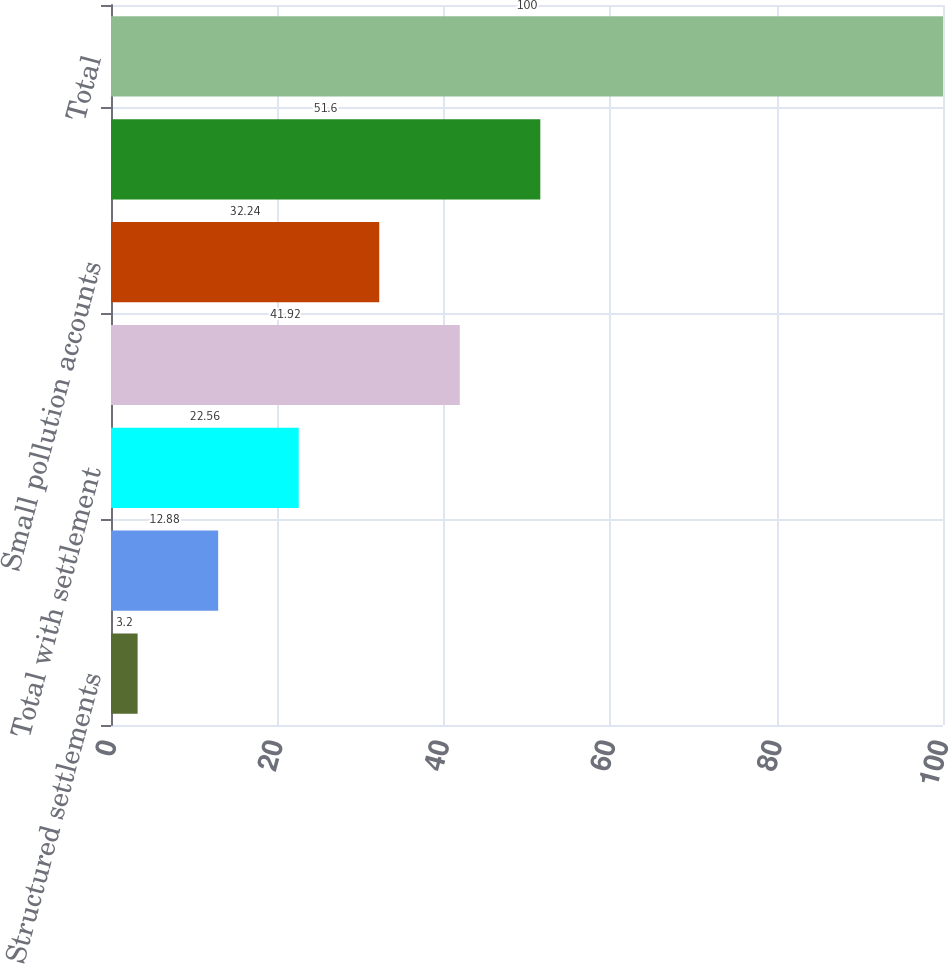Convert chart. <chart><loc_0><loc_0><loc_500><loc_500><bar_chart><fcel>Structured settlements<fcel>Coverage in place<fcel>Total with settlement<fcel>Large pollution accounts<fcel>Small pollution accounts<fcel>Total other policyholders<fcel>Total<nl><fcel>3.2<fcel>12.88<fcel>22.56<fcel>41.92<fcel>32.24<fcel>51.6<fcel>100<nl></chart> 